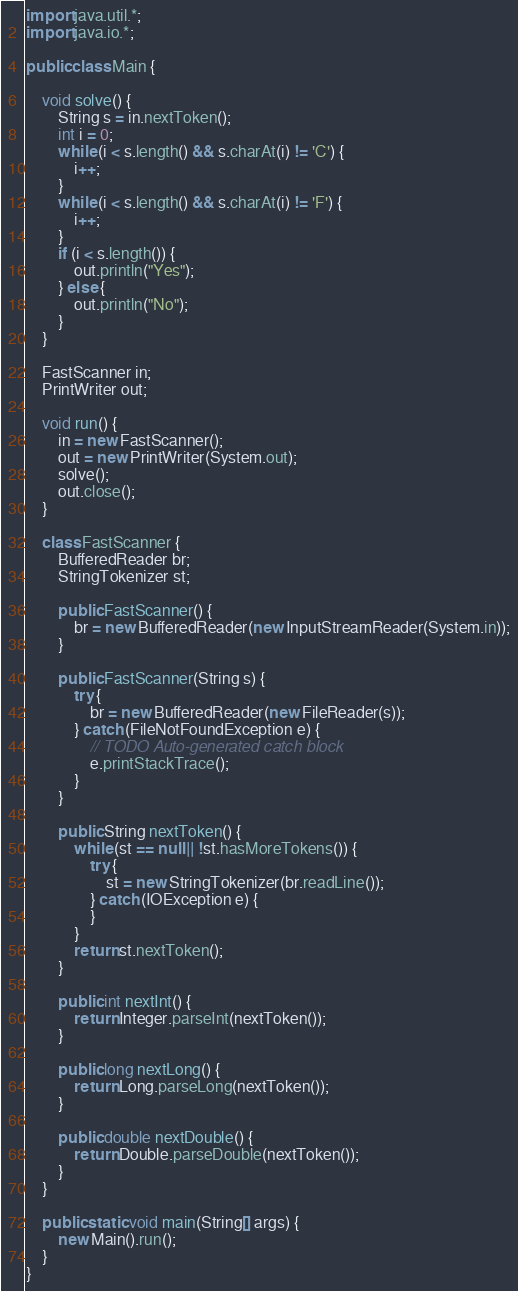Convert code to text. <code><loc_0><loc_0><loc_500><loc_500><_Java_>import java.util.*;
import java.io.*;

public class Main {

	void solve() {
		String s = in.nextToken();
		int i = 0;
		while (i < s.length() && s.charAt(i) != 'C') {
			i++;
		}
		while (i < s.length() && s.charAt(i) != 'F') {
			i++;
		}
		if (i < s.length()) {
			out.println("Yes");
		} else {
			out.println("No");
		}
	}

	FastScanner in;
	PrintWriter out;

	void run() {
		in = new FastScanner();
		out = new PrintWriter(System.out);
		solve();
		out.close();
	}

	class FastScanner {
		BufferedReader br;
		StringTokenizer st;

		public FastScanner() {
			br = new BufferedReader(new InputStreamReader(System.in));
		}

		public FastScanner(String s) {
			try {
				br = new BufferedReader(new FileReader(s));
			} catch (FileNotFoundException e) {
				// TODO Auto-generated catch block
				e.printStackTrace();
			}
		}

		public String nextToken() {
			while (st == null || !st.hasMoreTokens()) {
				try {
					st = new StringTokenizer(br.readLine());
				} catch (IOException e) {
				}
			}
			return st.nextToken();
		}

		public int nextInt() {
			return Integer.parseInt(nextToken());
		}

		public long nextLong() {
			return Long.parseLong(nextToken());
		}

		public double nextDouble() {
			return Double.parseDouble(nextToken());
		}
	}

	public static void main(String[] args) {
		new Main().run();
	}
}
</code> 